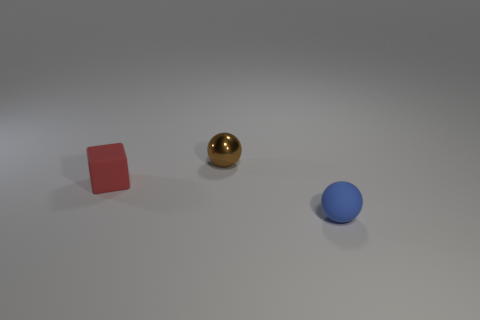Subtract 2 balls. How many balls are left? 0 Add 2 small brown shiny spheres. How many objects exist? 5 Subtract all blue spheres. How many spheres are left? 1 Subtract all rubber things. Subtract all brown blocks. How many objects are left? 1 Add 1 tiny rubber balls. How many tiny rubber balls are left? 2 Add 1 cyan rubber spheres. How many cyan rubber spheres exist? 1 Subtract 0 green blocks. How many objects are left? 3 Subtract all balls. How many objects are left? 1 Subtract all cyan balls. Subtract all purple cylinders. How many balls are left? 2 Subtract all yellow cylinders. How many brown cubes are left? 0 